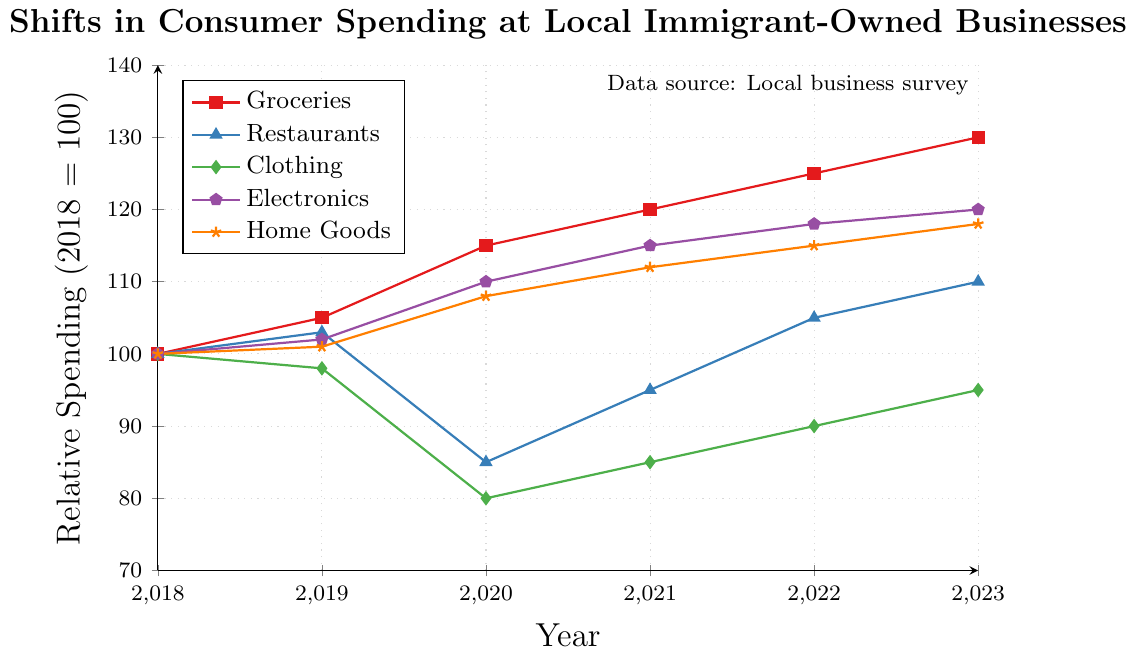what does the legend at the north west corner indicate? The legend at the top left corner of the graph identifies the various product categories and their corresponding colors and markers. This helps to visually distinguish between the different data series.
Answer: It indicates the product categories like Groceries, Restaurants, Clothing, Electronics, and Home Goods along with their respective colors and markers Which product category had the highest relative spending in 2020? To determine the highest spending category in 2020, look at the y-values corresponding to the year 2020 for all categories. The Groceries category reaches 115, the highest compared to other categories.
Answer: Groceries How has spending on restaurants changed from 2018 to 2023? To find the change in restaurant spending, compare the relative spending values for the years 2018 and 2023. The spending increased from 100 in 2018 to 110 in 2023.
Answer: Increased by 10% Which category experienced a decrease in spending between 2018 and 2020? Examine the plot for each product category from 2018 to 2020. Only the Clothing category shows a decrease, from 100 in 2018 to 80 in 2020.
Answer: Clothing By how much did spending on home goods increase from 2019 to 2023? Look at the values for home goods in 2019 and 2023. Subtract the 2019 value (101) from the 2023 value (118) to determine the increase.
Answer: Increased by 17 What is the average relative spending in 2021 for all categories? First, find the relative spending for each category in 2021: Groceries (120), Restaurants (95), Clothing (85), Electronics (115), Home Goods (112). Sum these values and divide by the number of categories (5). (120 + 95 + 85 + 115 + 112) / 5 = 105.4
Answer: 105.4 Which product category had the most consistent increase over the 5 years? Consistent increase implies regular and relatively uniform increments each year. Both Groceries and Electronics show this pattern, but Groceries has the most consistent and largest increments each year.
Answer: Groceries Which category showed the most volatile spending pattern from 2018 to 2023? A volatile pattern will have a lot of ups and downs. Restaurants, which went from 100 (2018) to 103 (2019), then down to 85 (2020), back up to 95 (2021), increasing to 105 (2022), and 110 (2023), appears the most volatile.
Answer: Restaurants Compare the spending trends for Electronics and Home Goods from 2018 to 2023. Electronics increased from 100 in 2018 to 120 in 2023, while Home Goods increased from 100 to 118 over the same period. Though both show an upward trend, Electronics had a slightly steeper increase.
Answer: Electronics increased faster What is the total increase in spending on groceries from 2018 to 2023? Groceries spending in 2018 was at 100 and increased to 130 by 2023. The total increase is 130 - 100.
Answer: Increased by 30 